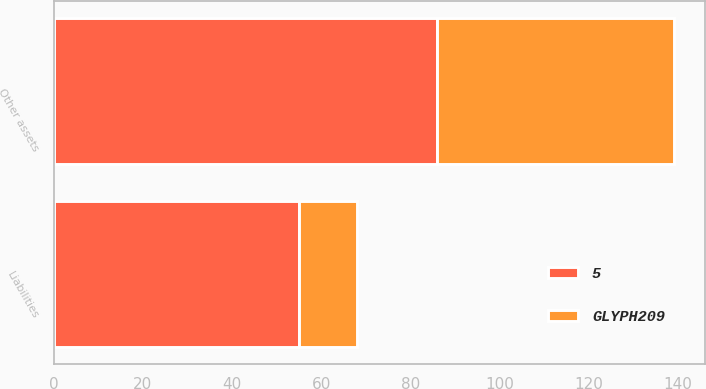Convert chart to OTSL. <chart><loc_0><loc_0><loc_500><loc_500><stacked_bar_chart><ecel><fcel>Other assets<fcel>Liabilities<nl><fcel>GLYPH209<fcel>53<fcel>13<nl><fcel>5<fcel>86<fcel>55<nl></chart> 